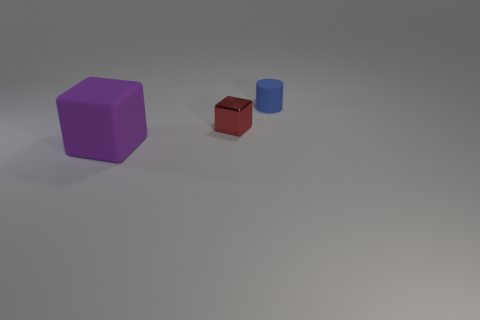Is there any other thing that is the same material as the small red block?
Offer a very short reply. No. Are there any other things that have the same shape as the small blue object?
Your response must be concise. No. There is a tiny thing in front of the blue matte cylinder; is its shape the same as the matte object in front of the rubber cylinder?
Your answer should be compact. Yes. There is a object that is both to the right of the purple thing and left of the blue cylinder; what is its color?
Offer a very short reply. Red. There is a rubber object left of the blue rubber cylinder; is it the same size as the rubber thing that is behind the small red block?
Make the answer very short. No. How many tiny things are either green metallic cylinders or red shiny objects?
Offer a terse response. 1. Do the thing that is in front of the small block and the tiny blue cylinder have the same material?
Your answer should be compact. Yes. There is a block that is to the right of the big cube; what color is it?
Your answer should be very brief. Red. Are there any blue objects that have the same size as the metal cube?
Your response must be concise. Yes. What is the material of the block that is the same size as the rubber cylinder?
Keep it short and to the point. Metal. 